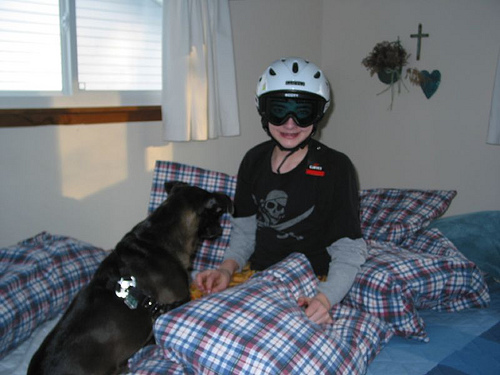<image>
Can you confirm if the heart is on the wall? Yes. Looking at the image, I can see the heart is positioned on top of the wall, with the wall providing support. Is there a man to the left of the dog? No. The man is not to the left of the dog. From this viewpoint, they have a different horizontal relationship. 